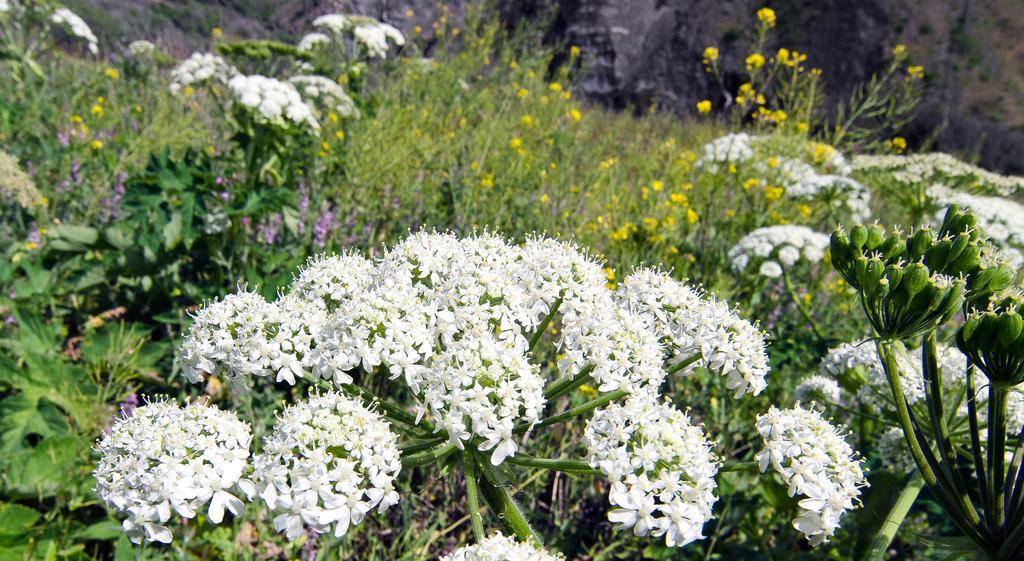In one or two sentences, can you explain what this image depicts? In this picture I can see flower plants. These flowers are white and yellow in color. 